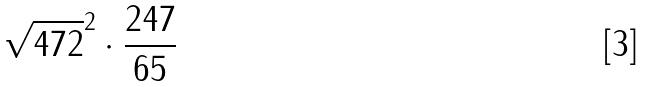Convert formula to latex. <formula><loc_0><loc_0><loc_500><loc_500>\sqrt { 4 7 2 } ^ { 2 } \cdot \frac { 2 4 7 } { 6 5 }</formula> 